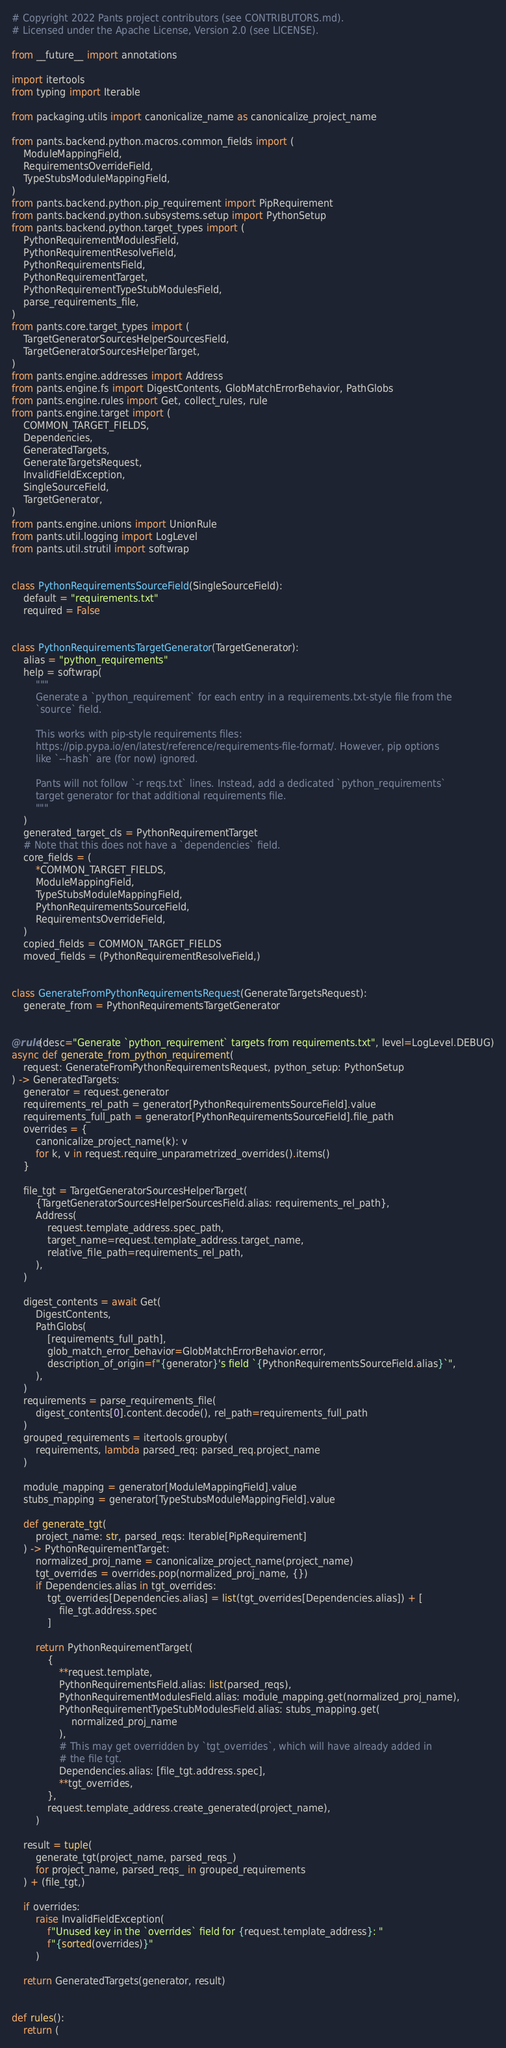<code> <loc_0><loc_0><loc_500><loc_500><_Python_># Copyright 2022 Pants project contributors (see CONTRIBUTORS.md).
# Licensed under the Apache License, Version 2.0 (see LICENSE).

from __future__ import annotations

import itertools
from typing import Iterable

from packaging.utils import canonicalize_name as canonicalize_project_name

from pants.backend.python.macros.common_fields import (
    ModuleMappingField,
    RequirementsOverrideField,
    TypeStubsModuleMappingField,
)
from pants.backend.python.pip_requirement import PipRequirement
from pants.backend.python.subsystems.setup import PythonSetup
from pants.backend.python.target_types import (
    PythonRequirementModulesField,
    PythonRequirementResolveField,
    PythonRequirementsField,
    PythonRequirementTarget,
    PythonRequirementTypeStubModulesField,
    parse_requirements_file,
)
from pants.core.target_types import (
    TargetGeneratorSourcesHelperSourcesField,
    TargetGeneratorSourcesHelperTarget,
)
from pants.engine.addresses import Address
from pants.engine.fs import DigestContents, GlobMatchErrorBehavior, PathGlobs
from pants.engine.rules import Get, collect_rules, rule
from pants.engine.target import (
    COMMON_TARGET_FIELDS,
    Dependencies,
    GeneratedTargets,
    GenerateTargetsRequest,
    InvalidFieldException,
    SingleSourceField,
    TargetGenerator,
)
from pants.engine.unions import UnionRule
from pants.util.logging import LogLevel
from pants.util.strutil import softwrap


class PythonRequirementsSourceField(SingleSourceField):
    default = "requirements.txt"
    required = False


class PythonRequirementsTargetGenerator(TargetGenerator):
    alias = "python_requirements"
    help = softwrap(
        """
        Generate a `python_requirement` for each entry in a requirements.txt-style file from the
        `source` field.

        This works with pip-style requirements files:
        https://pip.pypa.io/en/latest/reference/requirements-file-format/. However, pip options
        like `--hash` are (for now) ignored.

        Pants will not follow `-r reqs.txt` lines. Instead, add a dedicated `python_requirements`
        target generator for that additional requirements file.
        """
    )
    generated_target_cls = PythonRequirementTarget
    # Note that this does not have a `dependencies` field.
    core_fields = (
        *COMMON_TARGET_FIELDS,
        ModuleMappingField,
        TypeStubsModuleMappingField,
        PythonRequirementsSourceField,
        RequirementsOverrideField,
    )
    copied_fields = COMMON_TARGET_FIELDS
    moved_fields = (PythonRequirementResolveField,)


class GenerateFromPythonRequirementsRequest(GenerateTargetsRequest):
    generate_from = PythonRequirementsTargetGenerator


@rule(desc="Generate `python_requirement` targets from requirements.txt", level=LogLevel.DEBUG)
async def generate_from_python_requirement(
    request: GenerateFromPythonRequirementsRequest, python_setup: PythonSetup
) -> GeneratedTargets:
    generator = request.generator
    requirements_rel_path = generator[PythonRequirementsSourceField].value
    requirements_full_path = generator[PythonRequirementsSourceField].file_path
    overrides = {
        canonicalize_project_name(k): v
        for k, v in request.require_unparametrized_overrides().items()
    }

    file_tgt = TargetGeneratorSourcesHelperTarget(
        {TargetGeneratorSourcesHelperSourcesField.alias: requirements_rel_path},
        Address(
            request.template_address.spec_path,
            target_name=request.template_address.target_name,
            relative_file_path=requirements_rel_path,
        ),
    )

    digest_contents = await Get(
        DigestContents,
        PathGlobs(
            [requirements_full_path],
            glob_match_error_behavior=GlobMatchErrorBehavior.error,
            description_of_origin=f"{generator}'s field `{PythonRequirementsSourceField.alias}`",
        ),
    )
    requirements = parse_requirements_file(
        digest_contents[0].content.decode(), rel_path=requirements_full_path
    )
    grouped_requirements = itertools.groupby(
        requirements, lambda parsed_req: parsed_req.project_name
    )

    module_mapping = generator[ModuleMappingField].value
    stubs_mapping = generator[TypeStubsModuleMappingField].value

    def generate_tgt(
        project_name: str, parsed_reqs: Iterable[PipRequirement]
    ) -> PythonRequirementTarget:
        normalized_proj_name = canonicalize_project_name(project_name)
        tgt_overrides = overrides.pop(normalized_proj_name, {})
        if Dependencies.alias in tgt_overrides:
            tgt_overrides[Dependencies.alias] = list(tgt_overrides[Dependencies.alias]) + [
                file_tgt.address.spec
            ]

        return PythonRequirementTarget(
            {
                **request.template,
                PythonRequirementsField.alias: list(parsed_reqs),
                PythonRequirementModulesField.alias: module_mapping.get(normalized_proj_name),
                PythonRequirementTypeStubModulesField.alias: stubs_mapping.get(
                    normalized_proj_name
                ),
                # This may get overridden by `tgt_overrides`, which will have already added in
                # the file tgt.
                Dependencies.alias: [file_tgt.address.spec],
                **tgt_overrides,
            },
            request.template_address.create_generated(project_name),
        )

    result = tuple(
        generate_tgt(project_name, parsed_reqs_)
        for project_name, parsed_reqs_ in grouped_requirements
    ) + (file_tgt,)

    if overrides:
        raise InvalidFieldException(
            f"Unused key in the `overrides` field for {request.template_address}: "
            f"{sorted(overrides)}"
        )

    return GeneratedTargets(generator, result)


def rules():
    return (</code> 